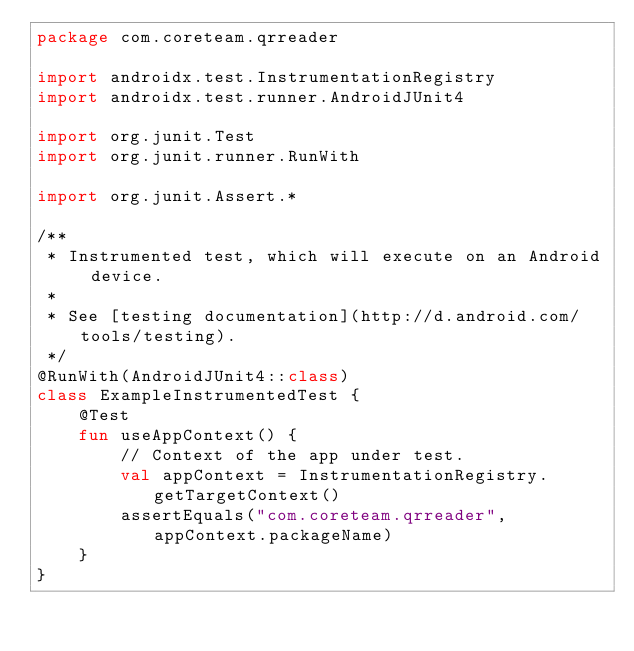<code> <loc_0><loc_0><loc_500><loc_500><_Kotlin_>package com.coreteam.qrreader

import androidx.test.InstrumentationRegistry
import androidx.test.runner.AndroidJUnit4

import org.junit.Test
import org.junit.runner.RunWith

import org.junit.Assert.*

/**
 * Instrumented test, which will execute on an Android device.
 *
 * See [testing documentation](http://d.android.com/tools/testing).
 */
@RunWith(AndroidJUnit4::class)
class ExampleInstrumentedTest {
    @Test
    fun useAppContext() {
        // Context of the app under test.
        val appContext = InstrumentationRegistry.getTargetContext()
        assertEquals("com.coreteam.qrreader", appContext.packageName)
    }
}
</code> 